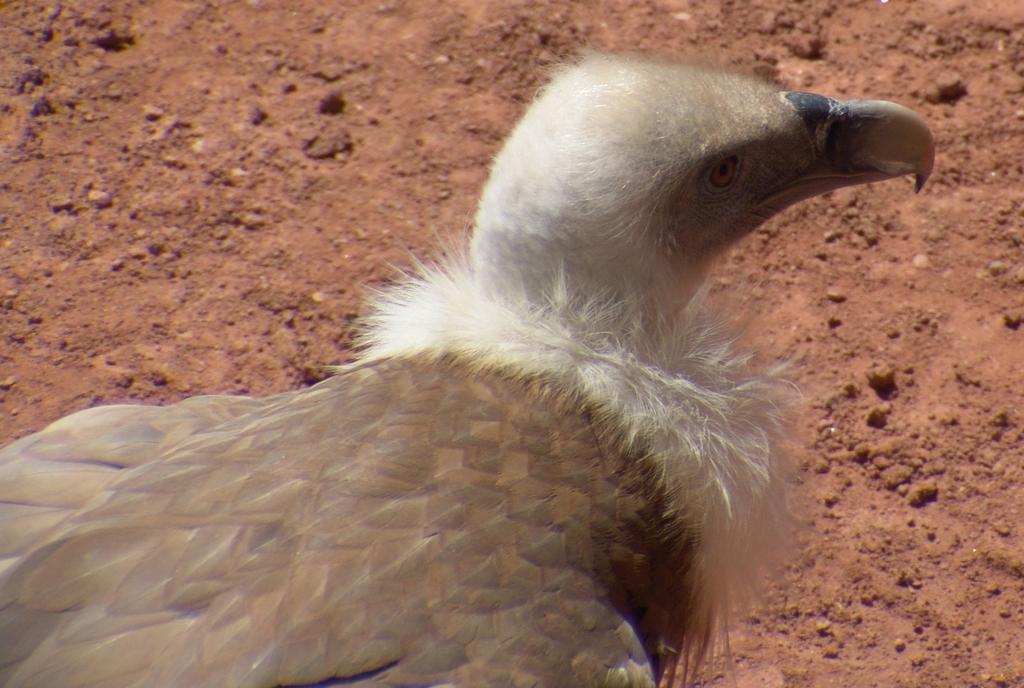How would you summarize this image in a sentence or two? In this image we can see a bird on the ground. 